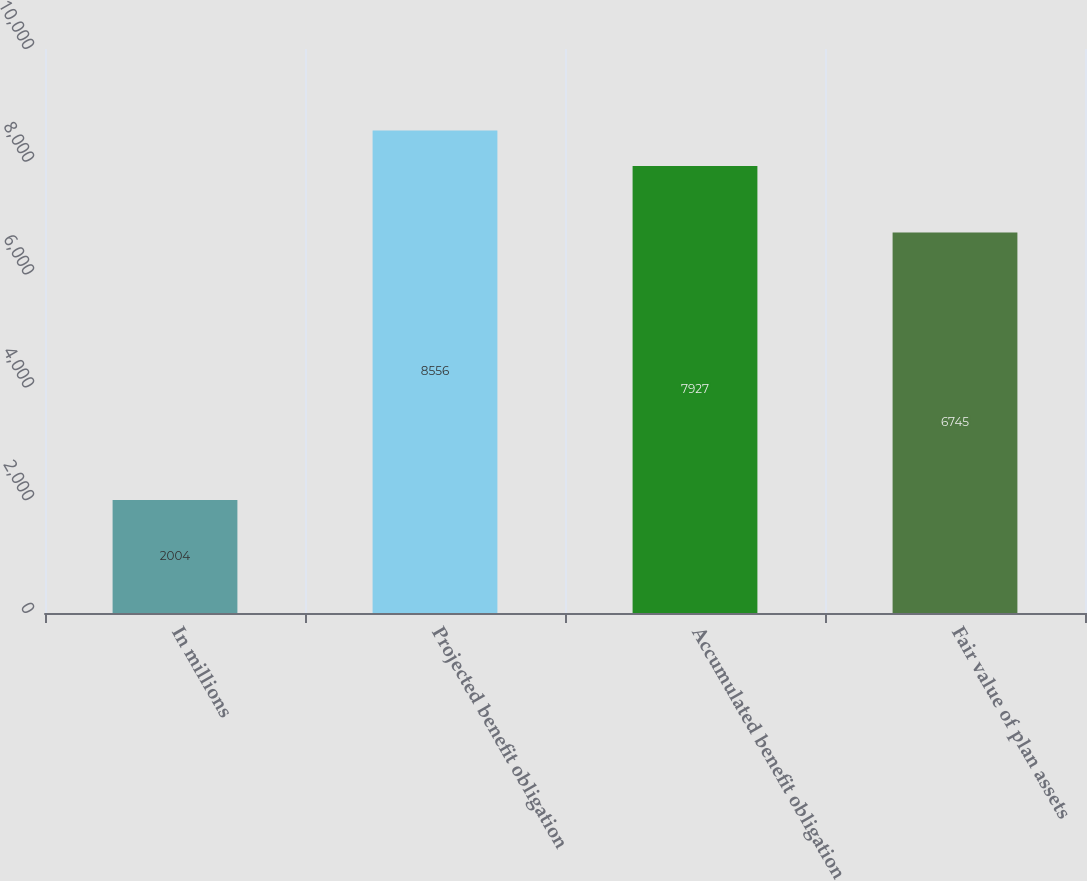Convert chart to OTSL. <chart><loc_0><loc_0><loc_500><loc_500><bar_chart><fcel>In millions<fcel>Projected benefit obligation<fcel>Accumulated benefit obligation<fcel>Fair value of plan assets<nl><fcel>2004<fcel>8556<fcel>7927<fcel>6745<nl></chart> 